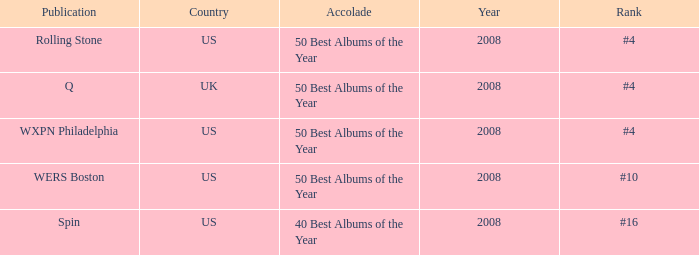Which year's rank was #4 when the country was the US? 2008, 2008. 